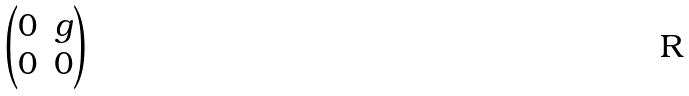Convert formula to latex. <formula><loc_0><loc_0><loc_500><loc_500>\begin{pmatrix} 0 & g \\ 0 & 0 \end{pmatrix}</formula> 